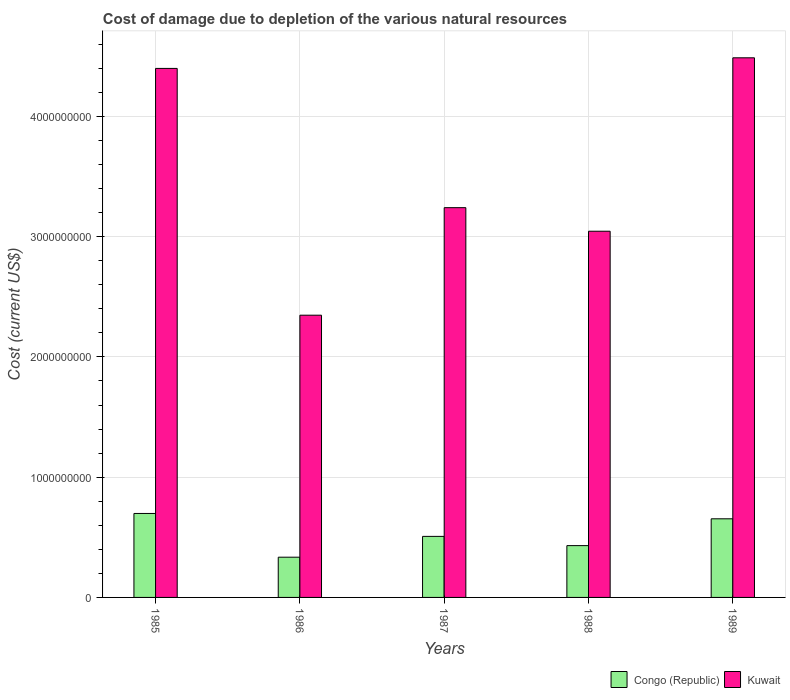How many different coloured bars are there?
Keep it short and to the point. 2. Are the number of bars per tick equal to the number of legend labels?
Provide a succinct answer. Yes. How many bars are there on the 5th tick from the right?
Ensure brevity in your answer.  2. What is the label of the 3rd group of bars from the left?
Your response must be concise. 1987. In how many cases, is the number of bars for a given year not equal to the number of legend labels?
Provide a succinct answer. 0. What is the cost of damage caused due to the depletion of various natural resources in Congo (Republic) in 1988?
Provide a short and direct response. 4.31e+08. Across all years, what is the maximum cost of damage caused due to the depletion of various natural resources in Kuwait?
Give a very brief answer. 4.49e+09. Across all years, what is the minimum cost of damage caused due to the depletion of various natural resources in Kuwait?
Offer a very short reply. 2.35e+09. In which year was the cost of damage caused due to the depletion of various natural resources in Kuwait minimum?
Keep it short and to the point. 1986. What is the total cost of damage caused due to the depletion of various natural resources in Congo (Republic) in the graph?
Your response must be concise. 2.63e+09. What is the difference between the cost of damage caused due to the depletion of various natural resources in Congo (Republic) in 1985 and that in 1986?
Ensure brevity in your answer.  3.64e+08. What is the difference between the cost of damage caused due to the depletion of various natural resources in Congo (Republic) in 1987 and the cost of damage caused due to the depletion of various natural resources in Kuwait in 1985?
Offer a terse response. -3.89e+09. What is the average cost of damage caused due to the depletion of various natural resources in Kuwait per year?
Your answer should be compact. 3.50e+09. In the year 1986, what is the difference between the cost of damage caused due to the depletion of various natural resources in Congo (Republic) and cost of damage caused due to the depletion of various natural resources in Kuwait?
Ensure brevity in your answer.  -2.01e+09. In how many years, is the cost of damage caused due to the depletion of various natural resources in Kuwait greater than 3400000000 US$?
Your answer should be very brief. 2. What is the ratio of the cost of damage caused due to the depletion of various natural resources in Kuwait in 1986 to that in 1989?
Your answer should be very brief. 0.52. Is the difference between the cost of damage caused due to the depletion of various natural resources in Congo (Republic) in 1988 and 1989 greater than the difference between the cost of damage caused due to the depletion of various natural resources in Kuwait in 1988 and 1989?
Provide a succinct answer. Yes. What is the difference between the highest and the second highest cost of damage caused due to the depletion of various natural resources in Congo (Republic)?
Make the answer very short. 4.44e+07. What is the difference between the highest and the lowest cost of damage caused due to the depletion of various natural resources in Kuwait?
Offer a very short reply. 2.14e+09. What does the 2nd bar from the left in 1988 represents?
Offer a terse response. Kuwait. What does the 1st bar from the right in 1986 represents?
Your response must be concise. Kuwait. How many bars are there?
Your answer should be very brief. 10. How many years are there in the graph?
Provide a succinct answer. 5. What is the difference between two consecutive major ticks on the Y-axis?
Give a very brief answer. 1.00e+09. Does the graph contain grids?
Keep it short and to the point. Yes. How many legend labels are there?
Offer a terse response. 2. How are the legend labels stacked?
Offer a very short reply. Horizontal. What is the title of the graph?
Offer a very short reply. Cost of damage due to depletion of the various natural resources. What is the label or title of the Y-axis?
Offer a very short reply. Cost (current US$). What is the Cost (current US$) of Congo (Republic) in 1985?
Your answer should be compact. 6.98e+08. What is the Cost (current US$) of Kuwait in 1985?
Keep it short and to the point. 4.40e+09. What is the Cost (current US$) in Congo (Republic) in 1986?
Make the answer very short. 3.35e+08. What is the Cost (current US$) of Kuwait in 1986?
Your answer should be very brief. 2.35e+09. What is the Cost (current US$) in Congo (Republic) in 1987?
Your answer should be very brief. 5.08e+08. What is the Cost (current US$) in Kuwait in 1987?
Provide a succinct answer. 3.24e+09. What is the Cost (current US$) of Congo (Republic) in 1988?
Keep it short and to the point. 4.31e+08. What is the Cost (current US$) in Kuwait in 1988?
Your answer should be compact. 3.05e+09. What is the Cost (current US$) in Congo (Republic) in 1989?
Provide a short and direct response. 6.54e+08. What is the Cost (current US$) in Kuwait in 1989?
Keep it short and to the point. 4.49e+09. Across all years, what is the maximum Cost (current US$) of Congo (Republic)?
Offer a terse response. 6.98e+08. Across all years, what is the maximum Cost (current US$) of Kuwait?
Keep it short and to the point. 4.49e+09. Across all years, what is the minimum Cost (current US$) of Congo (Republic)?
Provide a succinct answer. 3.35e+08. Across all years, what is the minimum Cost (current US$) in Kuwait?
Your response must be concise. 2.35e+09. What is the total Cost (current US$) of Congo (Republic) in the graph?
Your answer should be very brief. 2.63e+09. What is the total Cost (current US$) in Kuwait in the graph?
Offer a terse response. 1.75e+1. What is the difference between the Cost (current US$) in Congo (Republic) in 1985 and that in 1986?
Keep it short and to the point. 3.64e+08. What is the difference between the Cost (current US$) of Kuwait in 1985 and that in 1986?
Offer a very short reply. 2.05e+09. What is the difference between the Cost (current US$) in Congo (Republic) in 1985 and that in 1987?
Make the answer very short. 1.91e+08. What is the difference between the Cost (current US$) of Kuwait in 1985 and that in 1987?
Offer a terse response. 1.16e+09. What is the difference between the Cost (current US$) in Congo (Republic) in 1985 and that in 1988?
Give a very brief answer. 2.67e+08. What is the difference between the Cost (current US$) of Kuwait in 1985 and that in 1988?
Provide a short and direct response. 1.35e+09. What is the difference between the Cost (current US$) of Congo (Republic) in 1985 and that in 1989?
Your answer should be very brief. 4.44e+07. What is the difference between the Cost (current US$) of Kuwait in 1985 and that in 1989?
Your answer should be compact. -8.83e+07. What is the difference between the Cost (current US$) in Congo (Republic) in 1986 and that in 1987?
Make the answer very short. -1.73e+08. What is the difference between the Cost (current US$) in Kuwait in 1986 and that in 1987?
Your answer should be very brief. -8.94e+08. What is the difference between the Cost (current US$) of Congo (Republic) in 1986 and that in 1988?
Give a very brief answer. -9.63e+07. What is the difference between the Cost (current US$) in Kuwait in 1986 and that in 1988?
Keep it short and to the point. -6.98e+08. What is the difference between the Cost (current US$) of Congo (Republic) in 1986 and that in 1989?
Your answer should be compact. -3.19e+08. What is the difference between the Cost (current US$) in Kuwait in 1986 and that in 1989?
Provide a short and direct response. -2.14e+09. What is the difference between the Cost (current US$) in Congo (Republic) in 1987 and that in 1988?
Ensure brevity in your answer.  7.68e+07. What is the difference between the Cost (current US$) in Kuwait in 1987 and that in 1988?
Provide a succinct answer. 1.96e+08. What is the difference between the Cost (current US$) of Congo (Republic) in 1987 and that in 1989?
Provide a succinct answer. -1.46e+08. What is the difference between the Cost (current US$) of Kuwait in 1987 and that in 1989?
Your answer should be compact. -1.25e+09. What is the difference between the Cost (current US$) in Congo (Republic) in 1988 and that in 1989?
Give a very brief answer. -2.23e+08. What is the difference between the Cost (current US$) in Kuwait in 1988 and that in 1989?
Offer a terse response. -1.44e+09. What is the difference between the Cost (current US$) in Congo (Republic) in 1985 and the Cost (current US$) in Kuwait in 1986?
Give a very brief answer. -1.65e+09. What is the difference between the Cost (current US$) in Congo (Republic) in 1985 and the Cost (current US$) in Kuwait in 1987?
Your answer should be very brief. -2.54e+09. What is the difference between the Cost (current US$) of Congo (Republic) in 1985 and the Cost (current US$) of Kuwait in 1988?
Provide a succinct answer. -2.35e+09. What is the difference between the Cost (current US$) in Congo (Republic) in 1985 and the Cost (current US$) in Kuwait in 1989?
Your answer should be compact. -3.79e+09. What is the difference between the Cost (current US$) in Congo (Republic) in 1986 and the Cost (current US$) in Kuwait in 1987?
Provide a short and direct response. -2.91e+09. What is the difference between the Cost (current US$) of Congo (Republic) in 1986 and the Cost (current US$) of Kuwait in 1988?
Your answer should be compact. -2.71e+09. What is the difference between the Cost (current US$) in Congo (Republic) in 1986 and the Cost (current US$) in Kuwait in 1989?
Ensure brevity in your answer.  -4.15e+09. What is the difference between the Cost (current US$) in Congo (Republic) in 1987 and the Cost (current US$) in Kuwait in 1988?
Make the answer very short. -2.54e+09. What is the difference between the Cost (current US$) of Congo (Republic) in 1987 and the Cost (current US$) of Kuwait in 1989?
Ensure brevity in your answer.  -3.98e+09. What is the difference between the Cost (current US$) of Congo (Republic) in 1988 and the Cost (current US$) of Kuwait in 1989?
Your answer should be very brief. -4.06e+09. What is the average Cost (current US$) of Congo (Republic) per year?
Make the answer very short. 5.25e+08. What is the average Cost (current US$) of Kuwait per year?
Make the answer very short. 3.50e+09. In the year 1985, what is the difference between the Cost (current US$) in Congo (Republic) and Cost (current US$) in Kuwait?
Offer a terse response. -3.70e+09. In the year 1986, what is the difference between the Cost (current US$) in Congo (Republic) and Cost (current US$) in Kuwait?
Your answer should be very brief. -2.01e+09. In the year 1987, what is the difference between the Cost (current US$) in Congo (Republic) and Cost (current US$) in Kuwait?
Offer a very short reply. -2.73e+09. In the year 1988, what is the difference between the Cost (current US$) of Congo (Republic) and Cost (current US$) of Kuwait?
Offer a terse response. -2.61e+09. In the year 1989, what is the difference between the Cost (current US$) of Congo (Republic) and Cost (current US$) of Kuwait?
Offer a terse response. -3.83e+09. What is the ratio of the Cost (current US$) of Congo (Republic) in 1985 to that in 1986?
Give a very brief answer. 2.09. What is the ratio of the Cost (current US$) in Kuwait in 1985 to that in 1986?
Ensure brevity in your answer.  1.87. What is the ratio of the Cost (current US$) of Congo (Republic) in 1985 to that in 1987?
Provide a short and direct response. 1.38. What is the ratio of the Cost (current US$) in Kuwait in 1985 to that in 1987?
Make the answer very short. 1.36. What is the ratio of the Cost (current US$) of Congo (Republic) in 1985 to that in 1988?
Your answer should be compact. 1.62. What is the ratio of the Cost (current US$) of Kuwait in 1985 to that in 1988?
Make the answer very short. 1.44. What is the ratio of the Cost (current US$) in Congo (Republic) in 1985 to that in 1989?
Keep it short and to the point. 1.07. What is the ratio of the Cost (current US$) of Kuwait in 1985 to that in 1989?
Offer a terse response. 0.98. What is the ratio of the Cost (current US$) of Congo (Republic) in 1986 to that in 1987?
Your answer should be compact. 0.66. What is the ratio of the Cost (current US$) in Kuwait in 1986 to that in 1987?
Offer a very short reply. 0.72. What is the ratio of the Cost (current US$) of Congo (Republic) in 1986 to that in 1988?
Make the answer very short. 0.78. What is the ratio of the Cost (current US$) of Kuwait in 1986 to that in 1988?
Make the answer very short. 0.77. What is the ratio of the Cost (current US$) in Congo (Republic) in 1986 to that in 1989?
Provide a succinct answer. 0.51. What is the ratio of the Cost (current US$) of Kuwait in 1986 to that in 1989?
Your response must be concise. 0.52. What is the ratio of the Cost (current US$) of Congo (Republic) in 1987 to that in 1988?
Your response must be concise. 1.18. What is the ratio of the Cost (current US$) in Kuwait in 1987 to that in 1988?
Offer a terse response. 1.06. What is the ratio of the Cost (current US$) in Congo (Republic) in 1987 to that in 1989?
Make the answer very short. 0.78. What is the ratio of the Cost (current US$) in Kuwait in 1987 to that in 1989?
Offer a very short reply. 0.72. What is the ratio of the Cost (current US$) in Congo (Republic) in 1988 to that in 1989?
Provide a succinct answer. 0.66. What is the ratio of the Cost (current US$) in Kuwait in 1988 to that in 1989?
Give a very brief answer. 0.68. What is the difference between the highest and the second highest Cost (current US$) in Congo (Republic)?
Keep it short and to the point. 4.44e+07. What is the difference between the highest and the second highest Cost (current US$) in Kuwait?
Offer a terse response. 8.83e+07. What is the difference between the highest and the lowest Cost (current US$) in Congo (Republic)?
Provide a short and direct response. 3.64e+08. What is the difference between the highest and the lowest Cost (current US$) in Kuwait?
Offer a very short reply. 2.14e+09. 